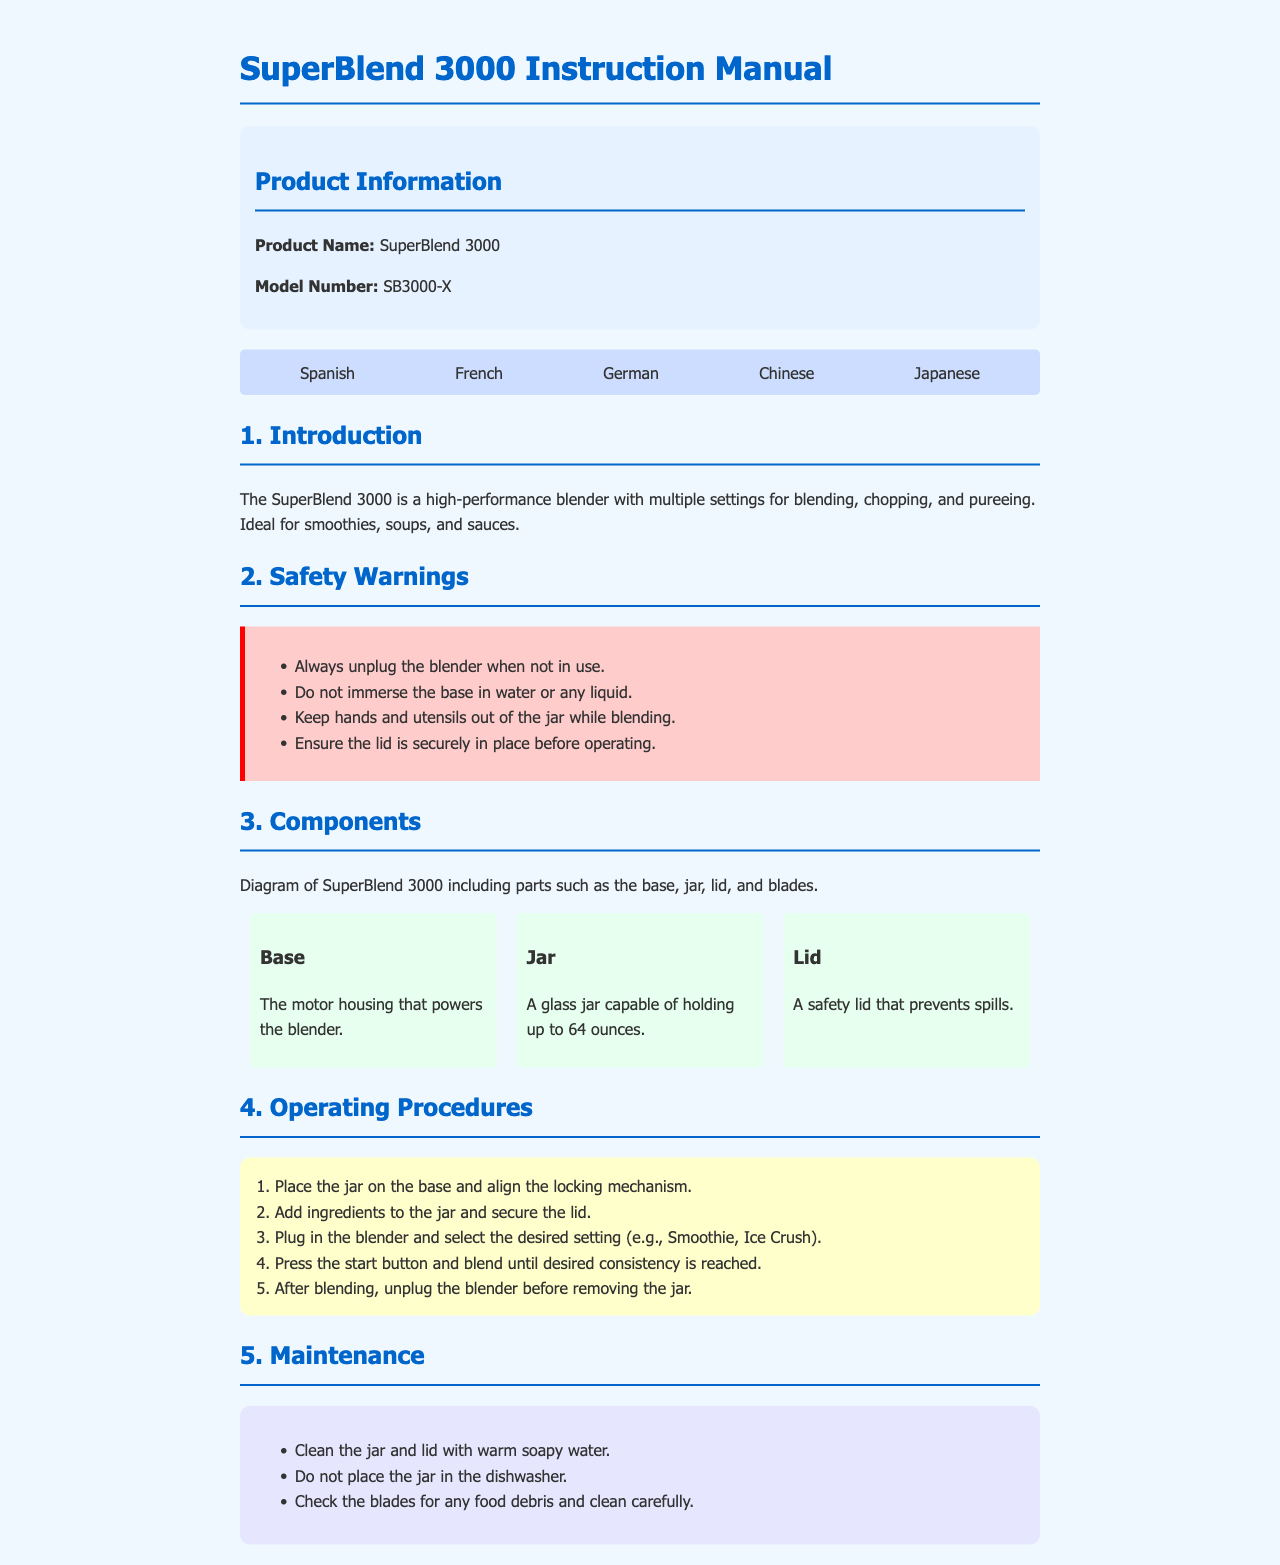What is the product name? The product name is found in the product information section of the manual.
Answer: SuperBlend 3000 What are the safety warnings about? The safety warnings mention precautions for safe operation of the blender.
Answer: Unplug, immersion, hands, lid How many ounces can the jar hold? The maximum capacity of the jar is specified in the components section.
Answer: 64 ounces What is the first step in the operating procedures? The first step for operating the blender is stated clearly in the steps section.
Answer: Place the jar How many languages is the manual available in? The number of languages is indicated by the different languages listed at the top of the document.
Answer: Five What care should be taken regarding the jar? Important maintenance tips for the jar are listed under the maintenance section.
Answer: No dishwasher Which part powers the blender? The part that powers the blender is described in the components section.
Answer: Base What should you do after blending? Instructions on what to do post-blending are found in the operating procedures section.
Answer: Unplug What color is the warning box? The color of the box containing safety warnings can be easily observed in the visuals of the document.
Answer: Red 